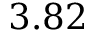<formula> <loc_0><loc_0><loc_500><loc_500>3 . 8 2</formula> 